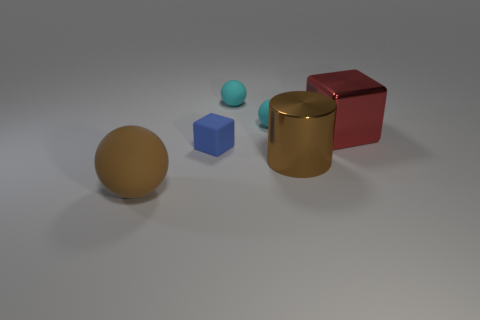What kind of setting does this picture suggest? This picture suggests a simple, possibly synthetic studio setting designed for showcasing or examining the objects without any distractions. The neutral grey background and lack of external context focus our attention solely on the shapes and their characteristics. 
How might these objects be used to explain basic geometry? These objects are perfect for explaining basic geometric concepts. For instance, the spheres can demonstrate curves and surfaces without edges, the cubes illustrate vertices, edges, and faces, and the cylinder could be used to discuss curved surfaces in combination with flat faces (circles at the top and bottom). 